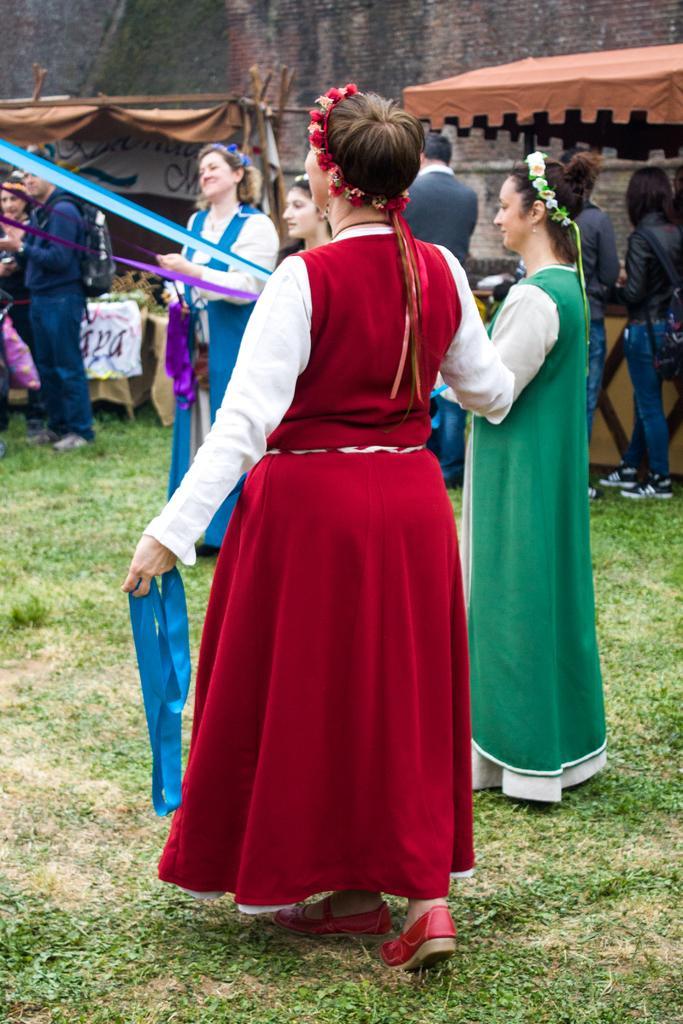How would you summarize this image in a sentence or two? In this image there are persons standing and walking. In the background there are tents and there are banners with some text written on it and there is a wall. In the center there is grass on the ground. 